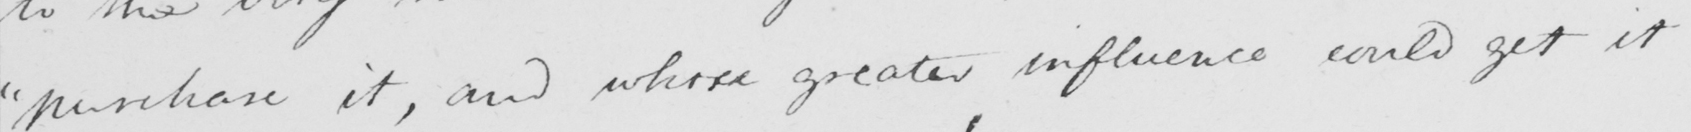What is written in this line of handwriting? " purchase it , and whose greater influence could get it 